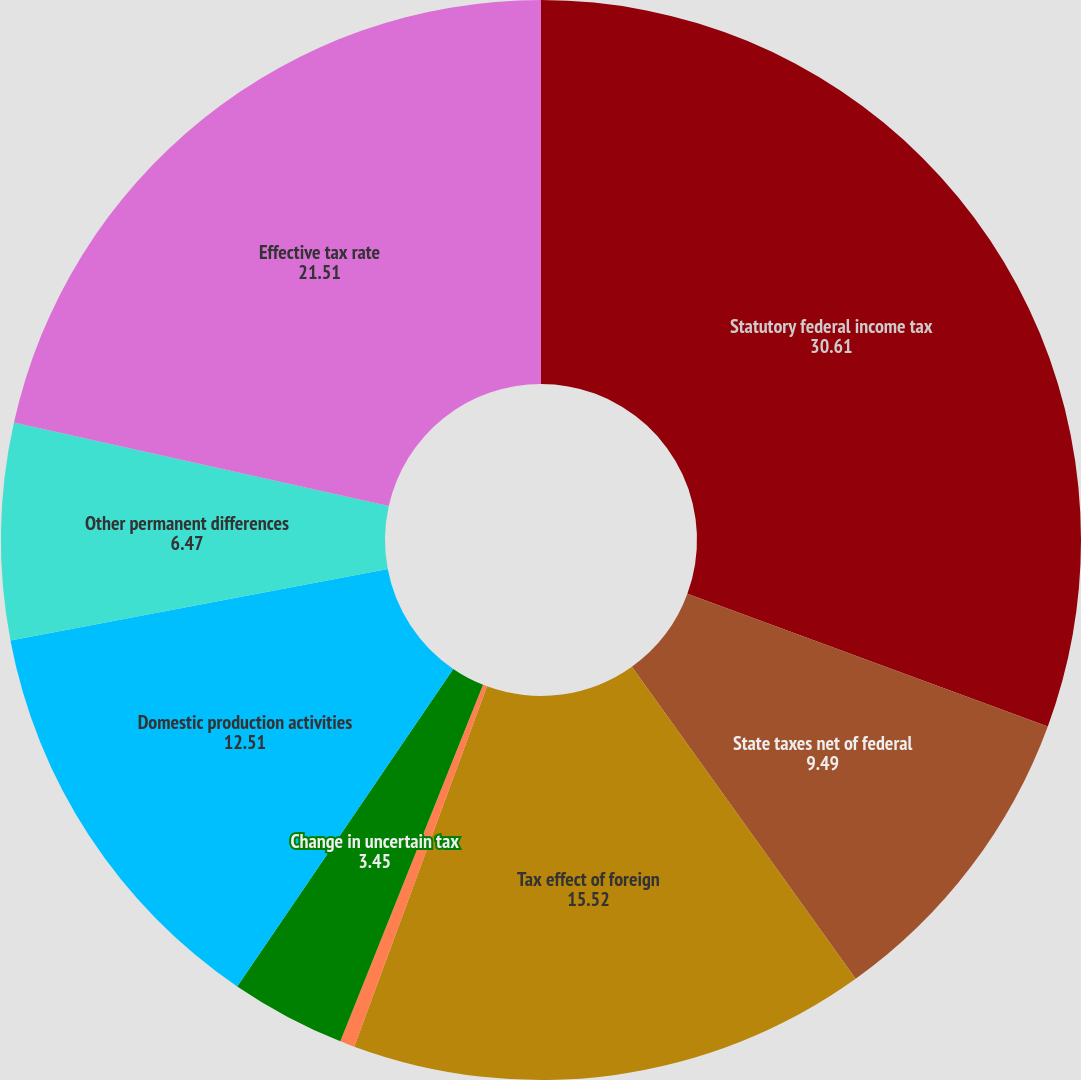<chart> <loc_0><loc_0><loc_500><loc_500><pie_chart><fcel>Statutory federal income tax<fcel>State taxes net of federal<fcel>Tax effect of foreign<fcel>Deferred tax on undistributed<fcel>Change in uncertain tax<fcel>Domestic production activities<fcel>Other permanent differences<fcel>Effective tax rate<nl><fcel>30.61%<fcel>9.49%<fcel>15.52%<fcel>0.44%<fcel>3.45%<fcel>12.51%<fcel>6.47%<fcel>21.51%<nl></chart> 